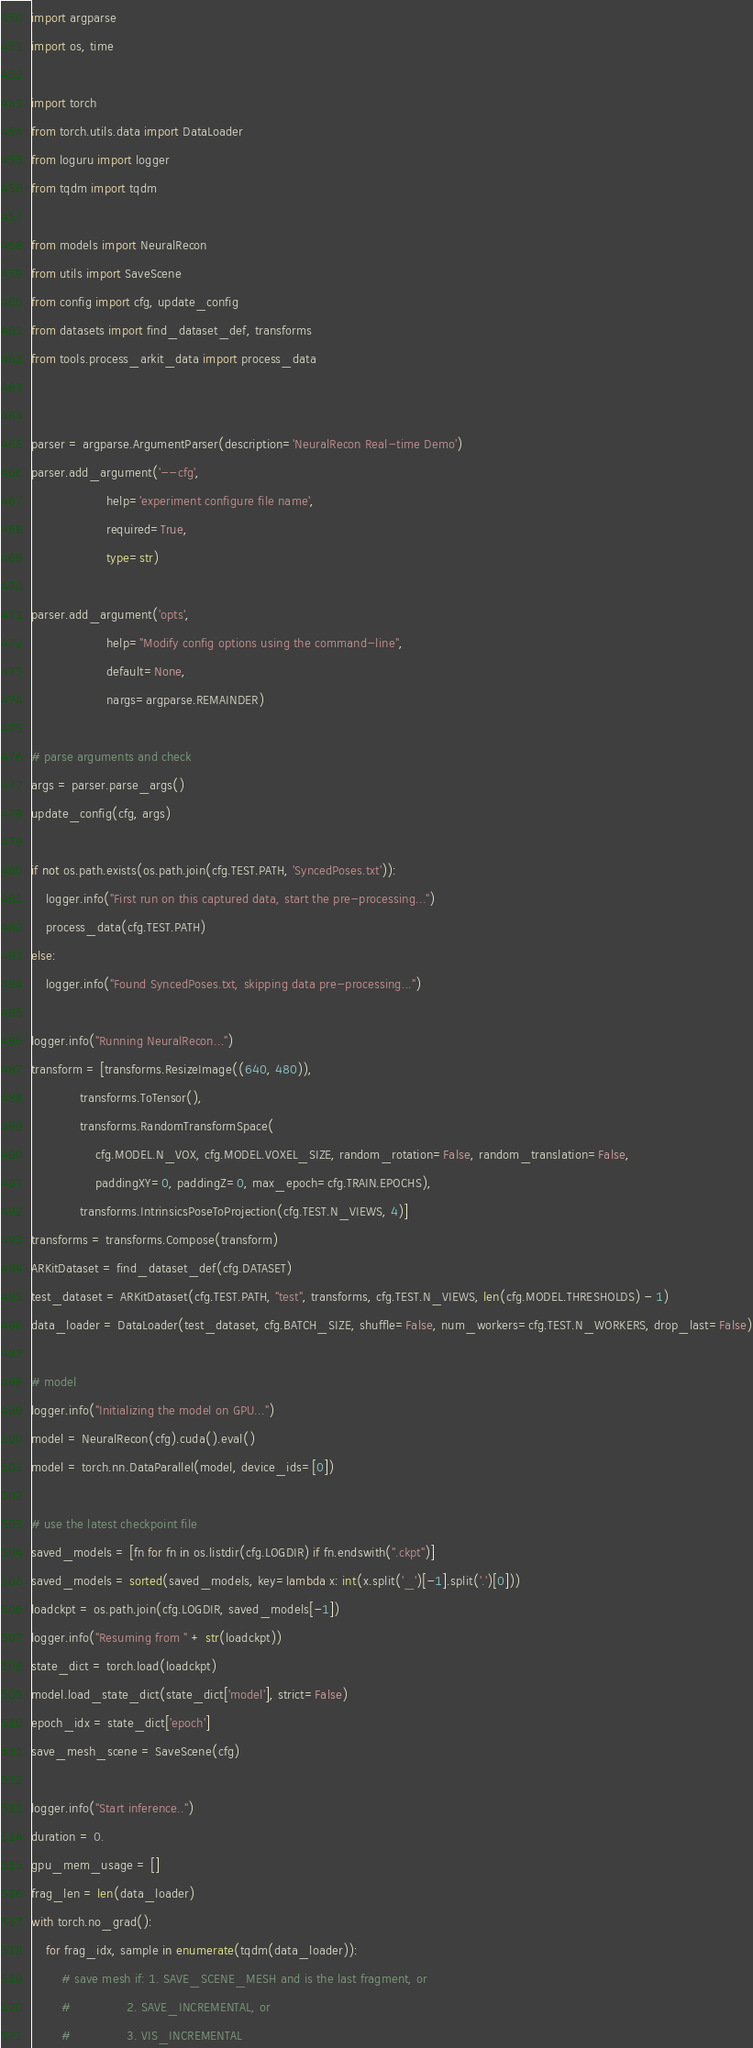<code> <loc_0><loc_0><loc_500><loc_500><_Python_>import argparse
import os, time

import torch
from torch.utils.data import DataLoader
from loguru import logger
from tqdm import tqdm

from models import NeuralRecon
from utils import SaveScene
from config import cfg, update_config
from datasets import find_dataset_def, transforms
from tools.process_arkit_data import process_data


parser = argparse.ArgumentParser(description='NeuralRecon Real-time Demo')
parser.add_argument('--cfg',
                    help='experiment configure file name',
                    required=True,
                    type=str)

parser.add_argument('opts',
                    help="Modify config options using the command-line",
                    default=None,
                    nargs=argparse.REMAINDER)

# parse arguments and check
args = parser.parse_args()
update_config(cfg, args)

if not os.path.exists(os.path.join(cfg.TEST.PATH, 'SyncedPoses.txt')):
    logger.info("First run on this captured data, start the pre-processing...")
    process_data(cfg.TEST.PATH)
else:
    logger.info("Found SyncedPoses.txt, skipping data pre-processing...")

logger.info("Running NeuralRecon...")
transform = [transforms.ResizeImage((640, 480)),
             transforms.ToTensor(),
             transforms.RandomTransformSpace(
                 cfg.MODEL.N_VOX, cfg.MODEL.VOXEL_SIZE, random_rotation=False, random_translation=False,
                 paddingXY=0, paddingZ=0, max_epoch=cfg.TRAIN.EPOCHS),
             transforms.IntrinsicsPoseToProjection(cfg.TEST.N_VIEWS, 4)]
transforms = transforms.Compose(transform)
ARKitDataset = find_dataset_def(cfg.DATASET)
test_dataset = ARKitDataset(cfg.TEST.PATH, "test", transforms, cfg.TEST.N_VIEWS, len(cfg.MODEL.THRESHOLDS) - 1)
data_loader = DataLoader(test_dataset, cfg.BATCH_SIZE, shuffle=False, num_workers=cfg.TEST.N_WORKERS, drop_last=False)

# model
logger.info("Initializing the model on GPU...")
model = NeuralRecon(cfg).cuda().eval()
model = torch.nn.DataParallel(model, device_ids=[0])

# use the latest checkpoint file
saved_models = [fn for fn in os.listdir(cfg.LOGDIR) if fn.endswith(".ckpt")]
saved_models = sorted(saved_models, key=lambda x: int(x.split('_')[-1].split('.')[0]))
loadckpt = os.path.join(cfg.LOGDIR, saved_models[-1])
logger.info("Resuming from " + str(loadckpt))
state_dict = torch.load(loadckpt)
model.load_state_dict(state_dict['model'], strict=False)
epoch_idx = state_dict['epoch']
save_mesh_scene = SaveScene(cfg)

logger.info("Start inference..")
duration = 0.
gpu_mem_usage = []
frag_len = len(data_loader)
with torch.no_grad():
    for frag_idx, sample in enumerate(tqdm(data_loader)):
        # save mesh if: 1. SAVE_SCENE_MESH and is the last fragment, or
        #               2. SAVE_INCREMENTAL, or
        #               3. VIS_INCREMENTAL</code> 